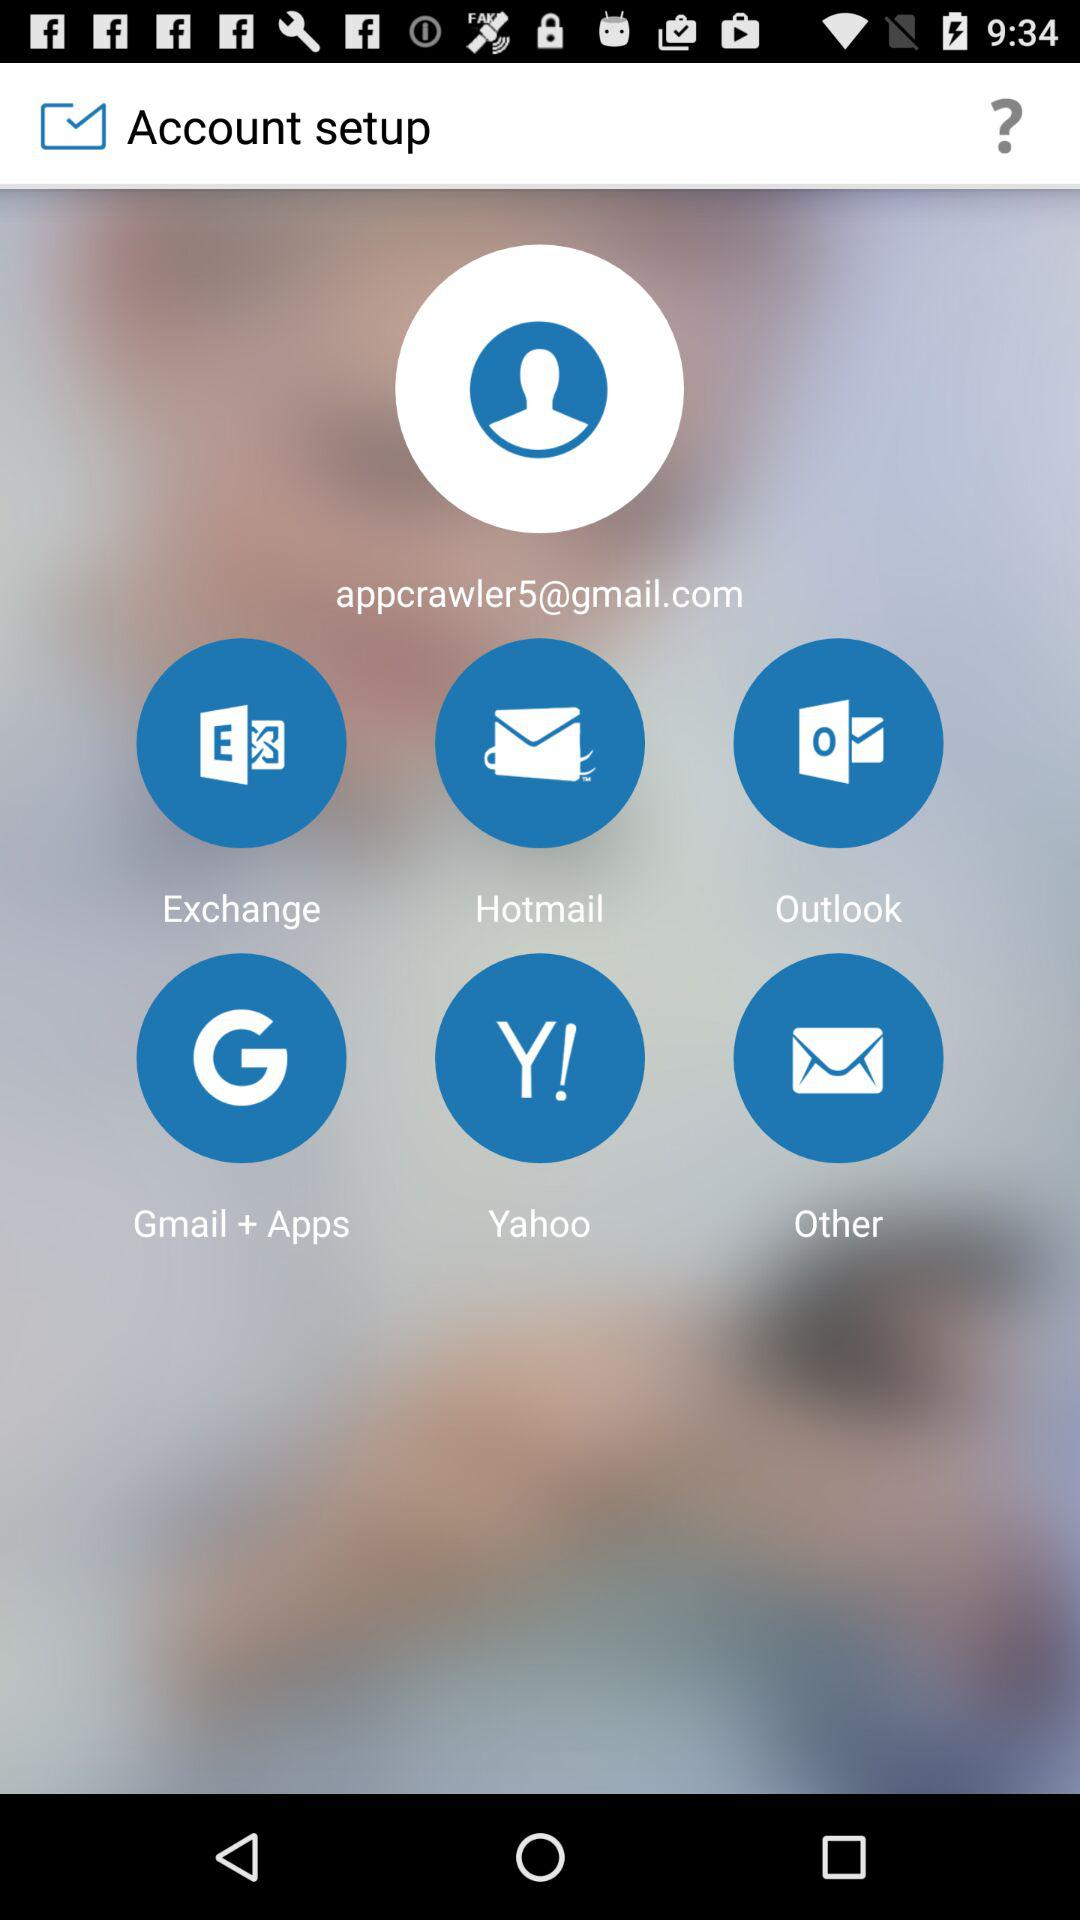Which options can I use for account setup? You can use the options "Exchange", "Hotmail", "Outlook", "Gmail + Apps", "Yahoo" and "Other" for account setup. 